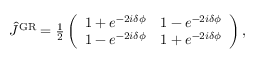<formula> <loc_0><loc_0><loc_500><loc_500>\begin{array} { r } { \hat { J } ^ { G R } = \frac { 1 } { 2 } \left ( \begin{array} { l l } { 1 + e ^ { - 2 i \delta \phi } } & { 1 - e ^ { - 2 i \delta \phi } } \\ { 1 - e ^ { - 2 i \delta \phi } } & { 1 + e ^ { - 2 i \delta \phi } } \end{array} \right ) , } \end{array}</formula> 